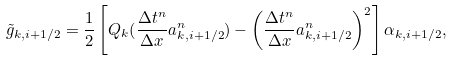Convert formula to latex. <formula><loc_0><loc_0><loc_500><loc_500>\tilde { g } _ { k , i + 1 / 2 } = \frac { 1 } { 2 } \left [ Q _ { k } ( \frac { \Delta t ^ { n } } { \Delta x } a _ { k , i + 1 / 2 } ^ { n } ) - \left ( \frac { \Delta t ^ { n } } { \Delta x } a _ { k , i + 1 / 2 } ^ { n } \right ) ^ { 2 } \right ] \alpha _ { k , i + 1 / 2 } ,</formula> 